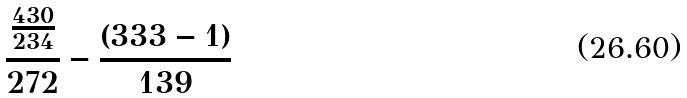<formula> <loc_0><loc_0><loc_500><loc_500>\frac { \frac { 4 3 0 } { 2 3 4 } } { 2 7 2 } - \frac { ( 3 3 3 - 1 ) } { 1 3 9 }</formula> 